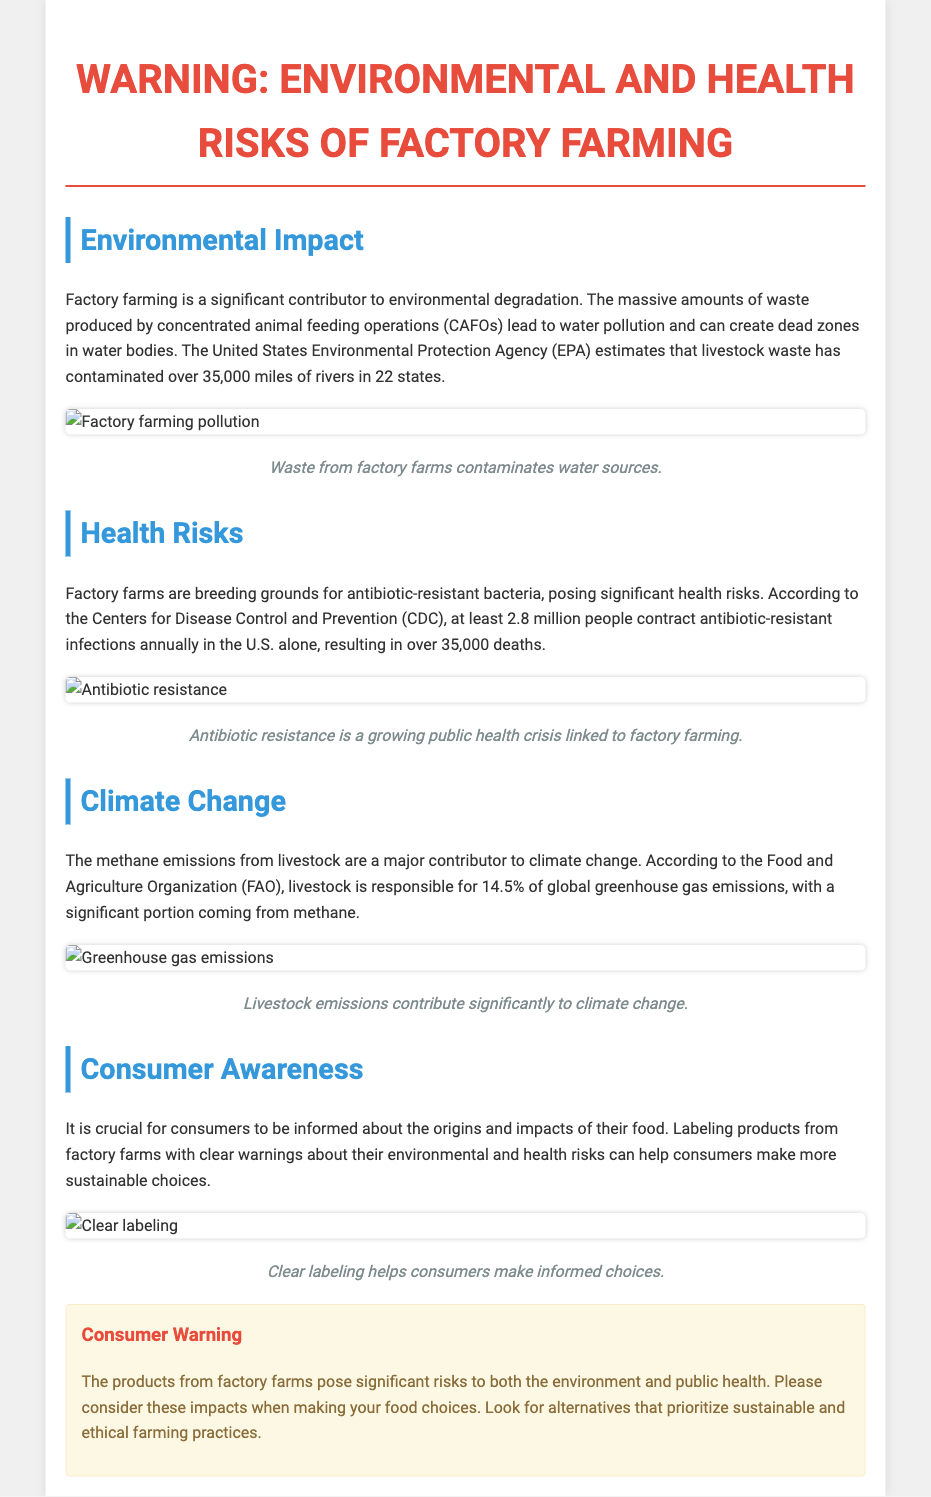What is the primary environmental concern of factory farming? The primary environmental concern mentioned is water pollution caused by livestock waste, which has contaminated over 35,000 miles of rivers in 22 states.
Answer: Water pollution What organization estimates livestock waste contamination? The organization that estimates this contamination is the United States Environmental Protection Agency (EPA).
Answer: EPA How many people contract antibiotic-resistant infections annually in the U.S.? According to the CDC, at least 2.8 million people contract these infections each year in the U.S.
Answer: 2.8 million What percentage of global greenhouse gas emissions is livestock responsible for? Livestock is responsible for 14.5% of global greenhouse gas emissions.
Answer: 14.5% What type of labeling is important for consumer awareness according to the document? The document emphasizes the importance of clear labeling for consumer awareness about factory farms' environmental and health risks.
Answer: Clear labeling Why is antibiotic resistance a concern related to factory farming? Antibiotic resistance is a concern because factory farms are breeding grounds for antibiotic-resistant bacteria, which pose significant health risks.
Answer: Breeding grounds What is the main message of the consumer warning? The main message of the consumer warning is to consider the environmental and public health risks posed by products from factory farms.
Answer: Consider risks According to the document, what should consumers look for when making food choices? Consumers should look for alternatives that prioritize sustainable and ethical farming practices.
Answer: Alternatives that prioritize sustainability 